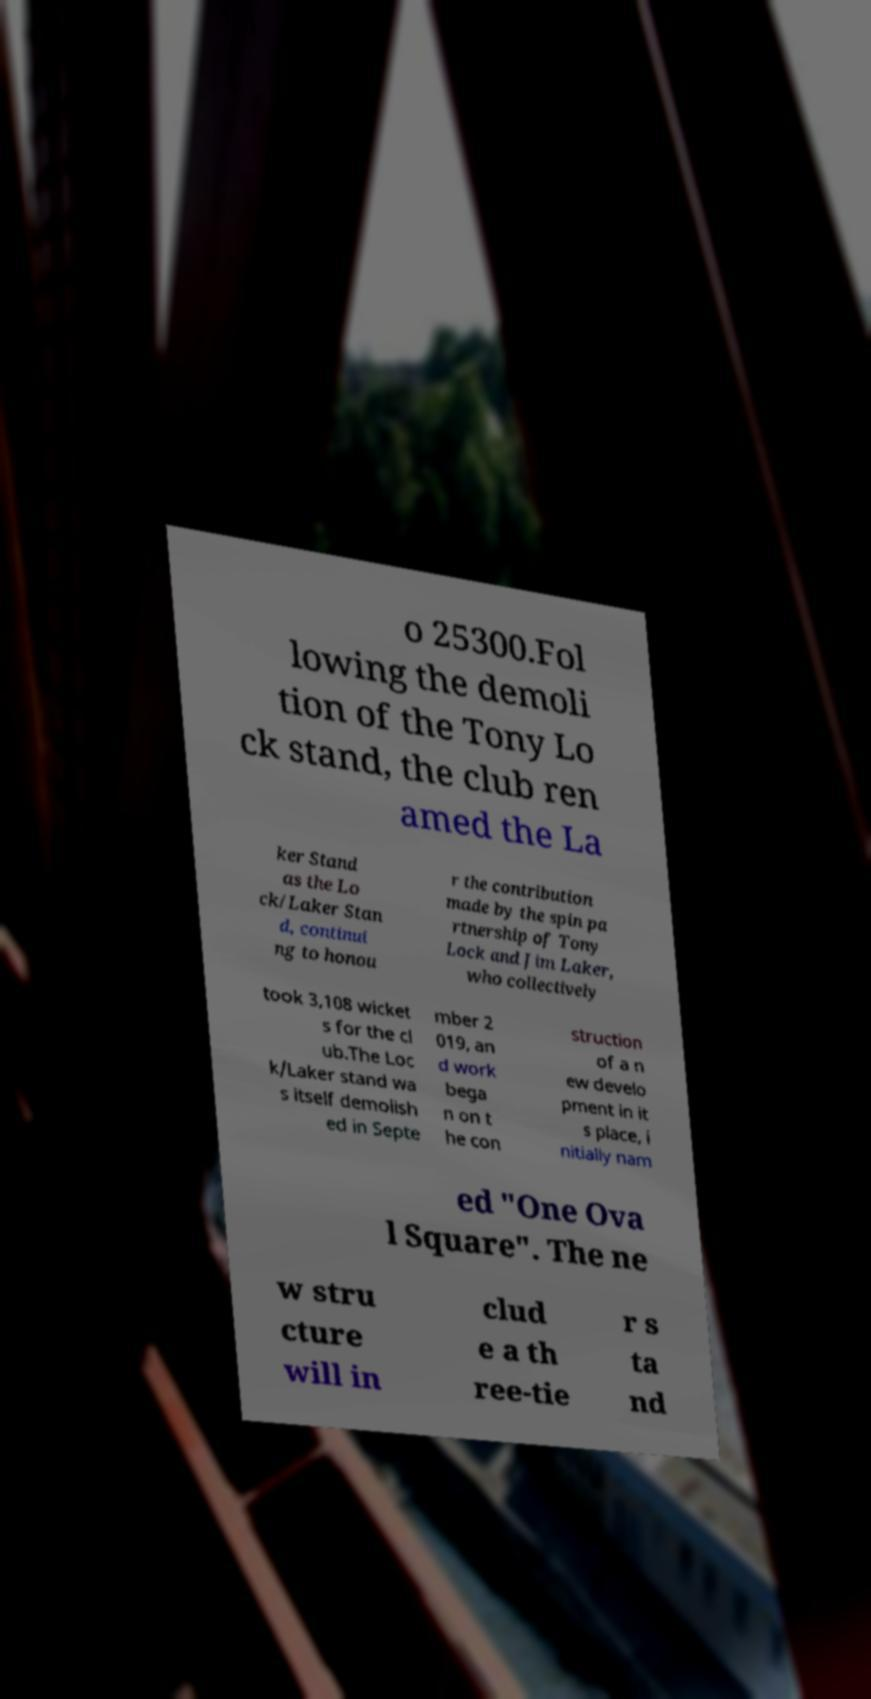I need the written content from this picture converted into text. Can you do that? o 25300.Fol lowing the demoli tion of the Tony Lo ck stand, the club ren amed the La ker Stand as the Lo ck/Laker Stan d, continui ng to honou r the contribution made by the spin pa rtnership of Tony Lock and Jim Laker, who collectively took 3,108 wicket s for the cl ub.The Loc k/Laker stand wa s itself demolish ed in Septe mber 2 019, an d work bega n on t he con struction of a n ew develo pment in it s place, i nitially nam ed "One Ova l Square". The ne w stru cture will in clud e a th ree-tie r s ta nd 